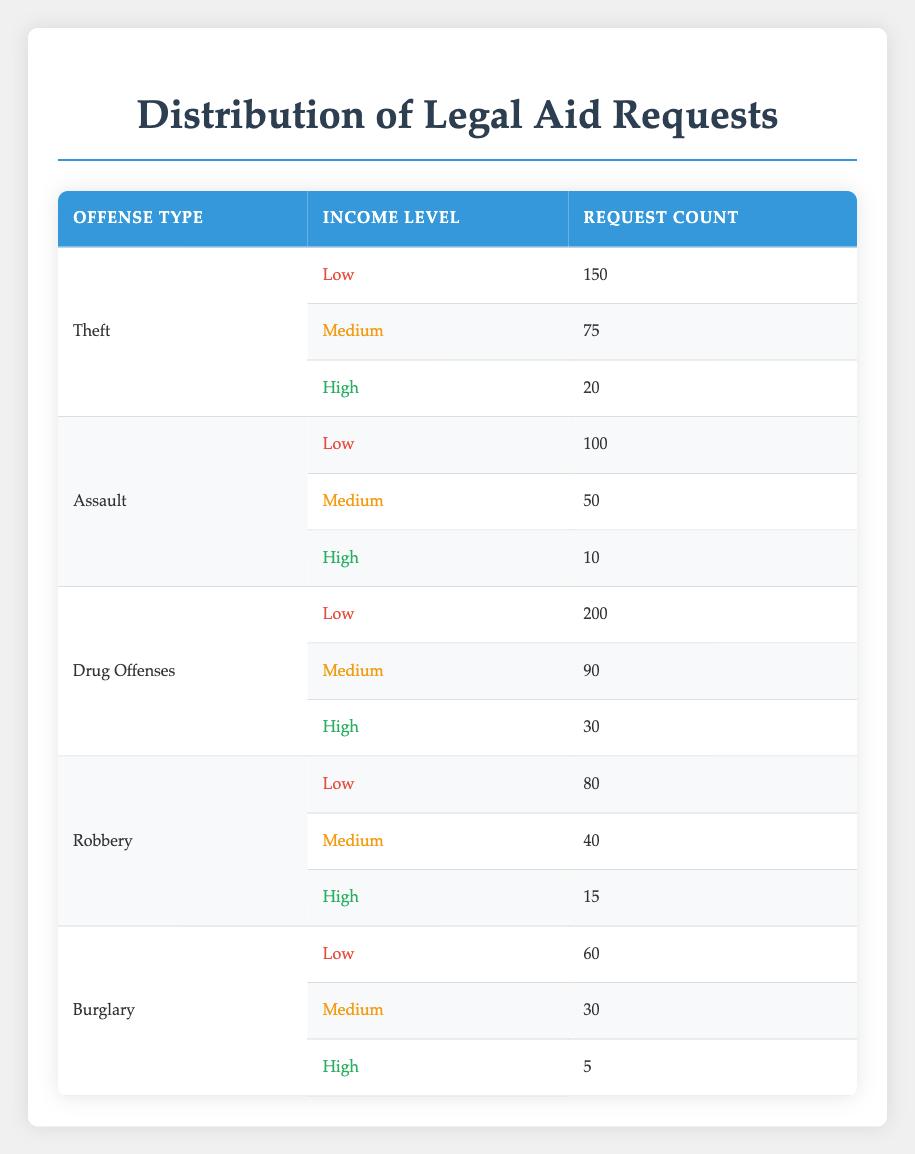What is the total number of legal aid requests for drug offenses? The table shows that there are three income levels for drug offenses: Low (200), Medium (90), and High (30). To find the total, we sum these values: 200 + 90 + 30 = 320.
Answer: 320 Which offense type has the highest request count for low-income applicants? Referring to the low-income row, Theft has 150 requests, Assault has 100, Drug Offenses has 200, Robbery has 80, and Burglary has 60. The maximum is 200 for Drug Offenses.
Answer: Drug Offenses Is the request count for medium-income applicants higher for Assault or Robbery? The medium-income request count for Assault is 50, while for Robbery, it is 40. Comparing these two numbers, 50 is greater than 40, so Assault has a higher count.
Answer: Yes What is the combined number of legal aid requests for high-income applicants across all offense types? For high-income applicants, the request counts are: Theft (20), Assault (10), Drug Offenses (30), Robbery (15), and Burglary (5). Summing these gives: 20 + 10 + 30 + 15 + 5 = 80.
Answer: 80 Which income level has the least requests for Burglary? Looking at the Burglary data, the request counts are Low (60), Medium (30), and High (5). The lowest count is for the High-income level at 5.
Answer: High How many more legal aid requests are there for low-income compared to high-income applicants for Theft? The request counts for Theft are: Low (150) and High (20). The difference is 150 - 20 = 130, indicating 130 more requests from low-income applicants.
Answer: 130 Which offense had the least number of legal aid requests overall? Summing the request counts for all offense types: Theft (245), Assault (160), Drug Offenses (320), Robbery (135), and Burglary (95). Burglary has the lowest total at 95.
Answer: Burglary What is the average number of legal aid requests for medium-income applicants across all offense types? The medium-income request counts are: Theft (75), Assault (50), Drug Offenses (90), Robbery (40), and Burglary (30). The total is 75 + 50 + 90 + 40 + 30 = 285, and there are five data points. The average is 285 / 5 = 57.
Answer: 57 What percentage of legal aid requests for Drug Offenses are from low-income applicants? Low-income requests for Drug Offenses account for 200 out of a total of 320 requests (200 + 90 + 30). To find the percentage, calculate (200 / 320) * 100, which equals 62.5%.
Answer: 62.5% 